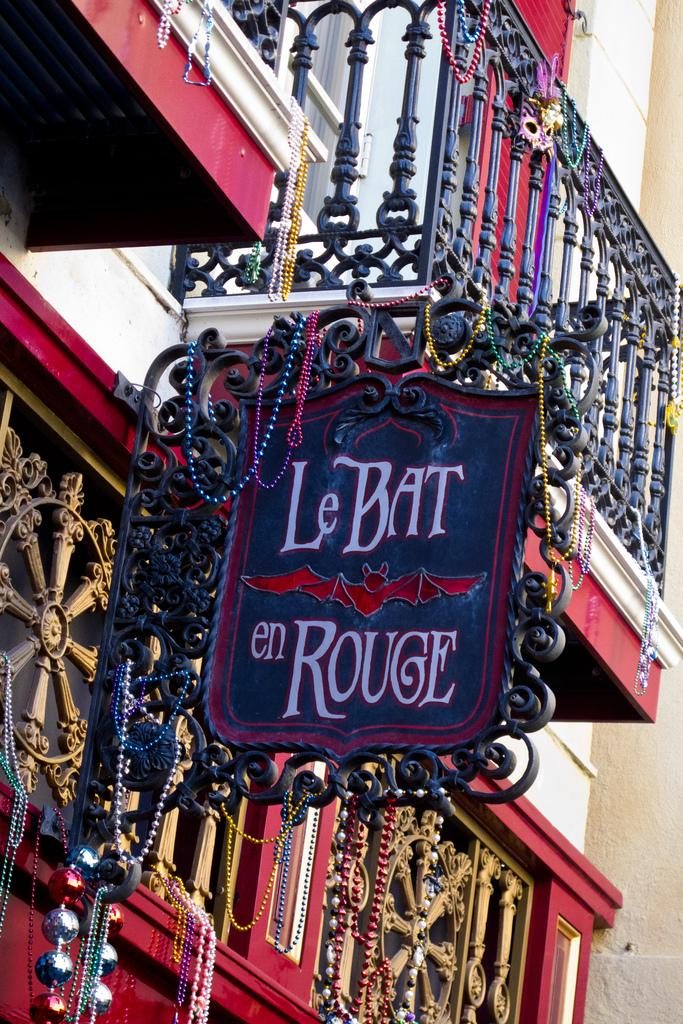What type of structure is visible in the image? There is a building in the image. What is attached to the building? There is a board with words in the image, and it has a bat picture on it. What other items can be seen in the image? There are many colorful lockets in the image. What type of grape is being used to decorate the bat picture on the board? There is no grape present in the image, and the bat picture on the board does not involve any decoration with grapes. 